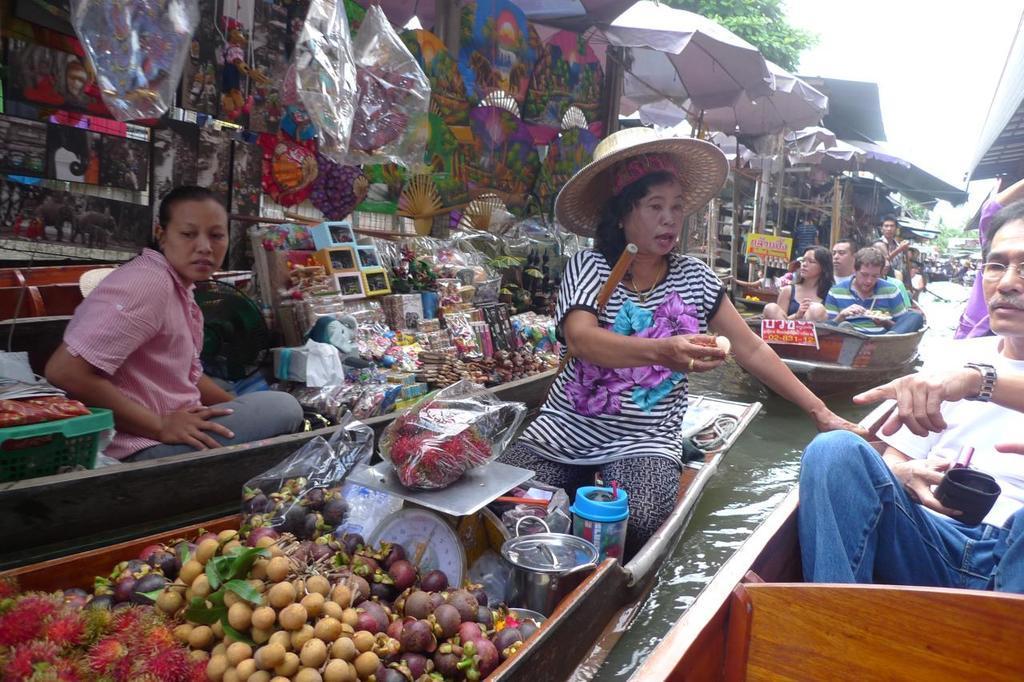In one or two sentences, can you explain what this image depicts? There are many boats on the water. On the right side a person wearing watch and specs is holding something in the hand. Near to her a lady is sitting on the boat is wearing hat and holding something in the hand. There are fruits, plastic cover, weighing machine and many other items on the boat. Also there is another lady sitting on the boat. On the boat there are many items. Near to her there is a wall with many items. In the back there is another boat with people. Also there are tents. 